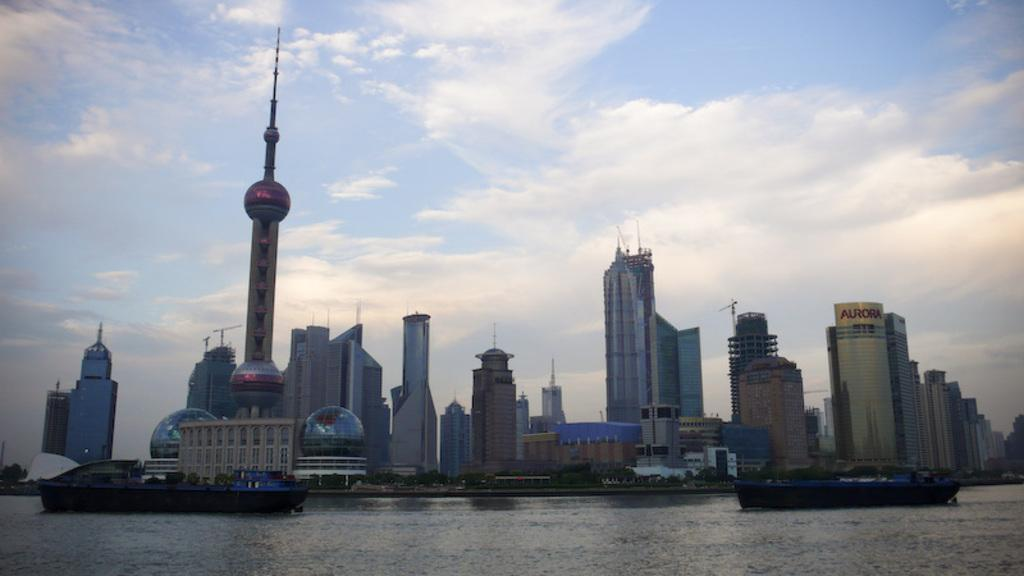What is the primary element in the image? There is water in the image. What can be seen floating on the water? There are boats in the image. What type of vegetation is visible in the background? There are trees in the background of the image. What type of structures are visible in the background? There are tall buildings in the background of the image. What is visible above the water and buildings? The sky is visible in the image. Can you tell me how many mint leaves are floating in the water? There are no mint leaves present in the image; it features water, boats, trees, tall buildings, and the sky. What type of spade is being used to dig in the water? There is no spade present in the image, and no digging is taking place. 